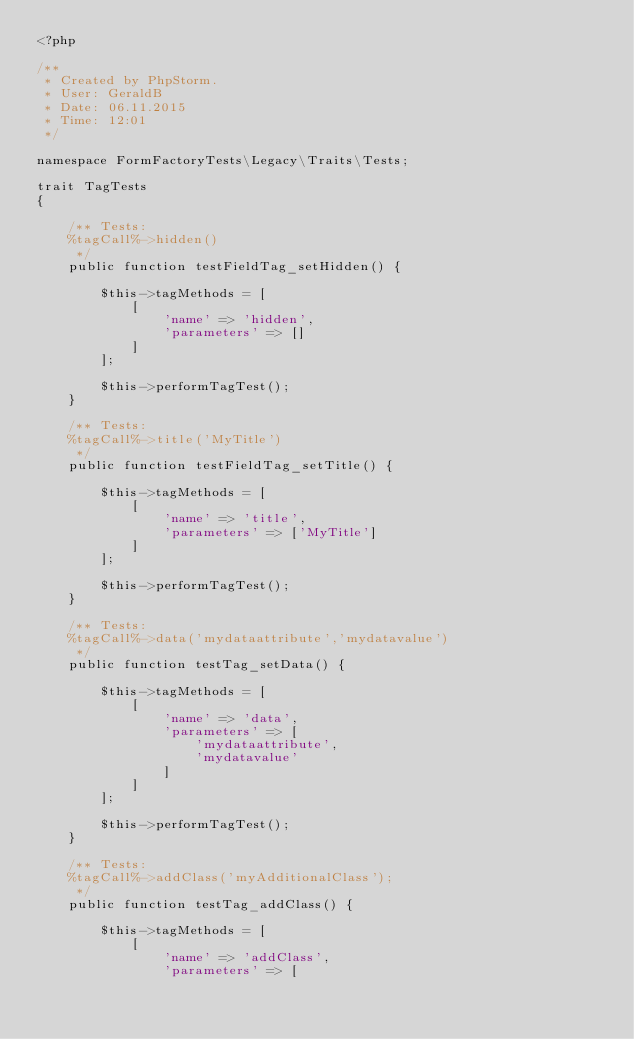<code> <loc_0><loc_0><loc_500><loc_500><_PHP_><?php

/**
 * Created by PhpStorm.
 * User: GeraldB
 * Date: 06.11.2015
 * Time: 12:01
 */

namespace FormFactoryTests\Legacy\Traits\Tests;

trait TagTests
{

    /** Tests:
    %tagCall%->hidden()
     */
    public function testFieldTag_setHidden() {

        $this->tagMethods = [
            [
                'name' => 'hidden',
                'parameters' => []
            ]
        ];

        $this->performTagTest();
    }

    /** Tests:
    %tagCall%->title('MyTitle')
     */
    public function testFieldTag_setTitle() {

        $this->tagMethods = [
            [
                'name' => 'title',
                'parameters' => ['MyTitle']
            ]
        ];

        $this->performTagTest();
    }

    /** Tests:
    %tagCall%->data('mydataattribute','mydatavalue')
     */
    public function testTag_setData() {

        $this->tagMethods = [
            [
                'name' => 'data',
                'parameters' => [
                    'mydataattribute',
                    'mydatavalue'
                ]
            ]
        ];

        $this->performTagTest();
    }

    /** Tests:
    %tagCall%->addClass('myAdditionalClass');
     */
    public function testTag_addClass() {

        $this->tagMethods = [
            [
                'name' => 'addClass',
                'parameters' => [</code> 